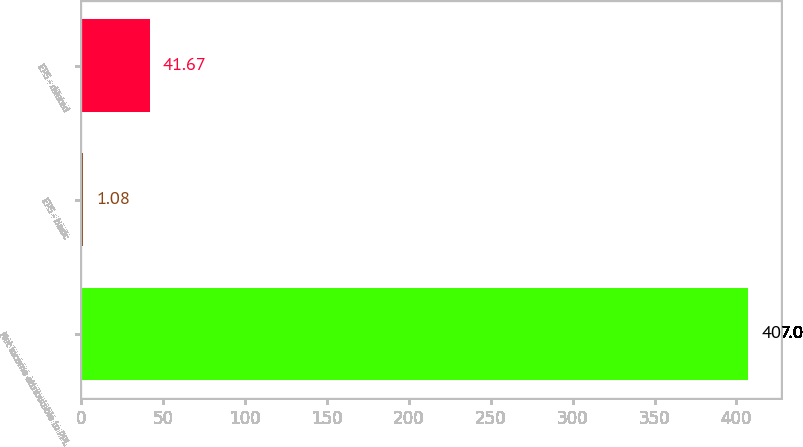<chart> <loc_0><loc_0><loc_500><loc_500><bar_chart><fcel>Net income attributable to PPL<fcel>EPS - basic<fcel>EPS - diluted<nl><fcel>407<fcel>1.08<fcel>41.67<nl></chart> 